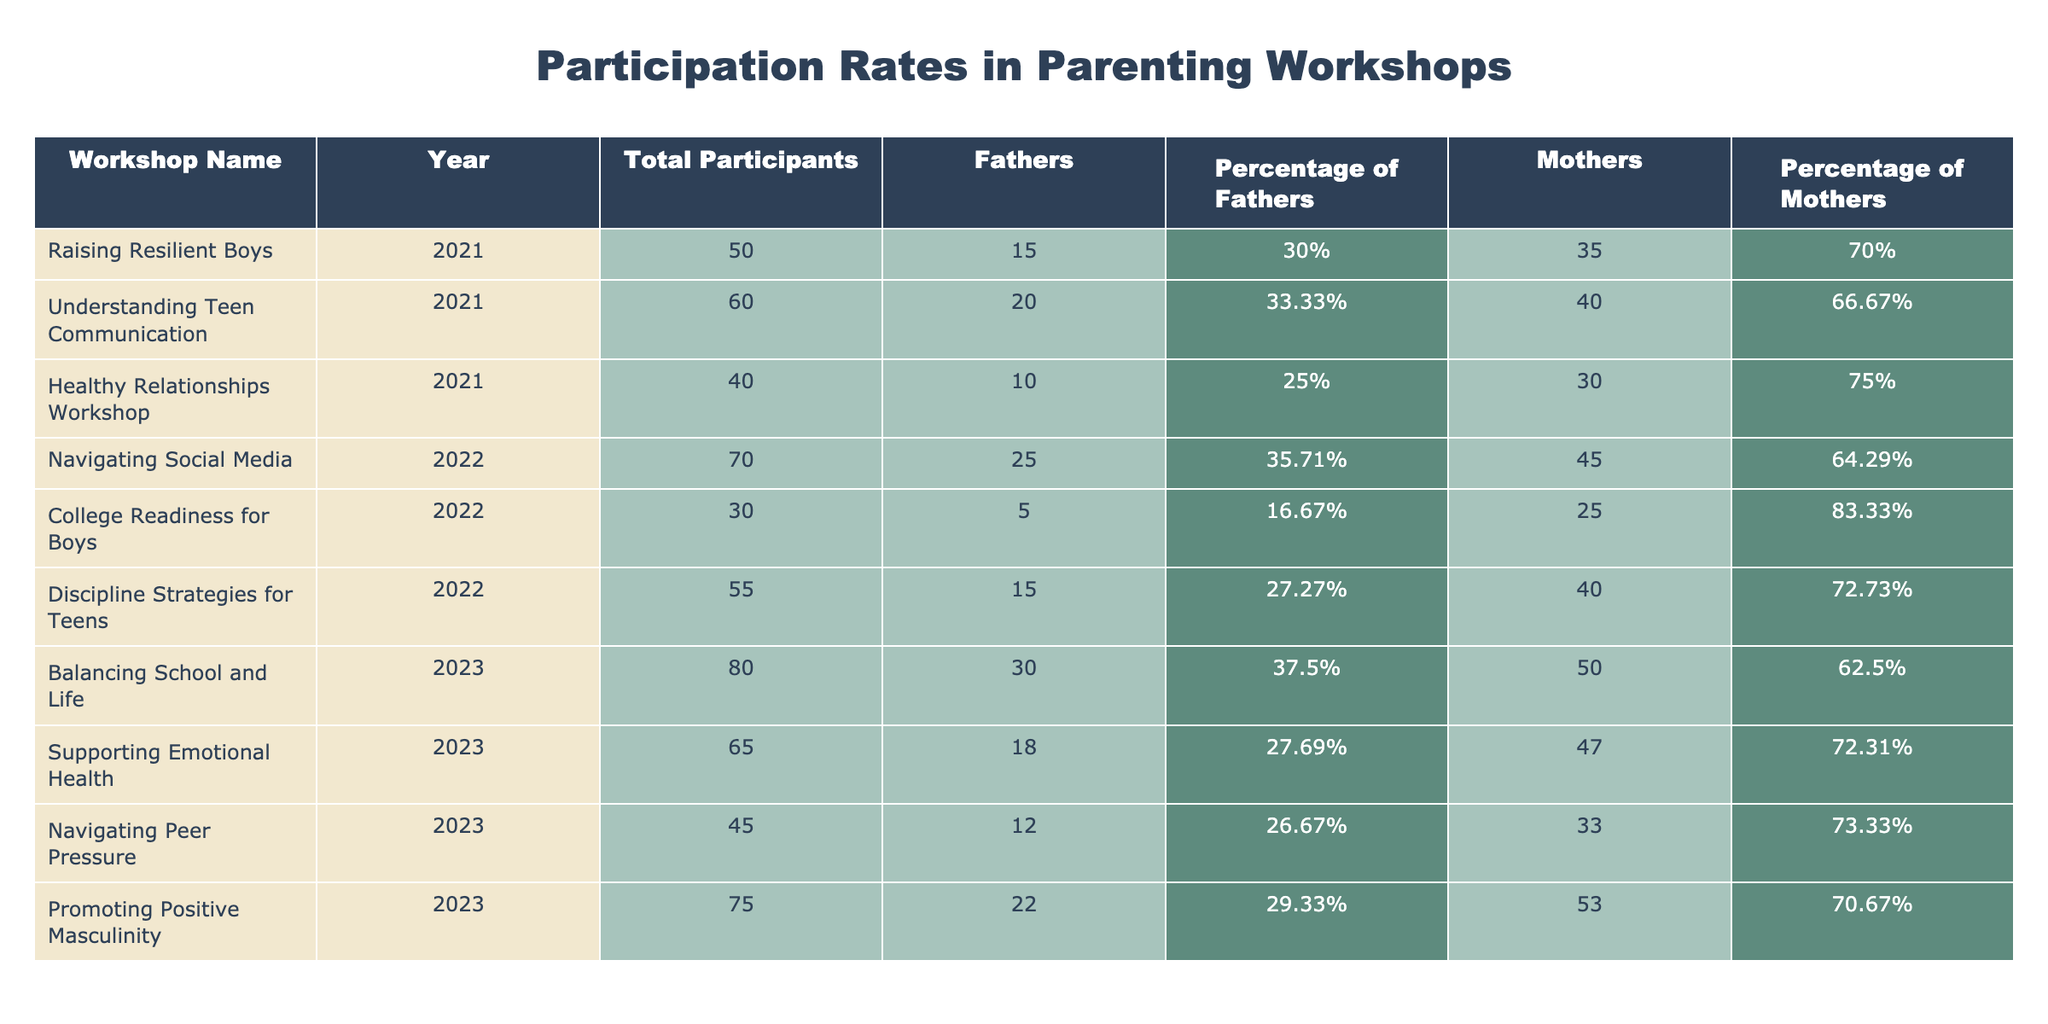What is the total number of fathers who participated in the "Understanding Teen Communication" workshop? In the table, for the workshop "Understanding Teen Communication," the number of fathers is specifically listed under the column "Fathers." The value shown is 20.
Answer: 20 What percentage of participants were fathers in the "College Readiness for Boys" workshop? Looking at the "College Readiness for Boys" entry, the column "Percentage of Fathers" indicates 16.67%, which represents the share of fathers among all participants in that workshop.
Answer: 16.67% Which workshop had the highest percentage of mothers participating? By comparing the "Percentage of Mothers" column across all workshops, "College Readiness for Boys" has the highest percentage at 83.33%.
Answer: 83.33% What is the total number of participants across all workshops for the year 2021? To find the total participants for 2021, I look at the "Total Participants" values for each workshop in that year: 50 (Raising Resilient Boys) + 60 (Understanding Teen Communication) + 40 (Healthy Relationships Workshop) = 150.
Answer: 150 True or False: More fathers than mothers attended the "Navigating Social Media" workshop. In the "Navigating Social Media" row, the number of fathers is 25, and the number of mothers is 45. Since 25 is less than 45, the statement is false.
Answer: False What is the average number of fathers attending the workshops in 2022? The workshops in 2022 are "Navigating Social Media," "College Readiness for Boys," and "Discipline Strategies for Teens," which have 25, 5, and 15 fathers respectively. The sum is 25 + 5 + 15 = 45. There are 3 workshops, so the average is 45/3 = 15.
Answer: 15 Which workshop in 2023 had the lowest attendance of fathers? To find this, I check the "Fathers" column for the workshops in 2023: Balancing School and Life (30), Supporting Emotional Health (18), Navigating Peer Pressure (12), and Promoting Positive Masculinity (22). The lowest value is 12 for Navigating Peer Pressure.
Answer: Navigating Peer Pressure How many more mothers than fathers attended the "Promoting Positive Masculinity" workshop? In the "Promoting Positive Masculinity" row, the number of mothers is 53, and the number of fathers is 22. The difference is calculated as 53 - 22 = 31.
Answer: 31 Which year had the highest overall participation in workshops? To determine the year with the highest overall participation, sum the "Total Participants" for each year: 2021 (150), 2022 (155), and 2023 (190). The highest sum, 190, is for the year 2023.
Answer: 2023 What is the total percentage of fathers across all workshops in 2021? To find the total percentage of fathers in 2021, I calculate the weighted average based on the number of participants: (15/50 * 100) + (20/60 * 100) + (10/40 * 100) = 30% + 33.33% + 25% = 88.33 total respondants in the 3 events. Then take the total number and divide (total fathers 45/total participants 150) = 30%.
Answer: 30% 